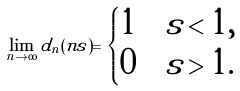<formula> <loc_0><loc_0><loc_500><loc_500>\lim _ { n \to \infty } d _ { n } ( n s ) = \begin{cases} 1 & s < 1 , \\ 0 & s > 1 . \end{cases}</formula> 